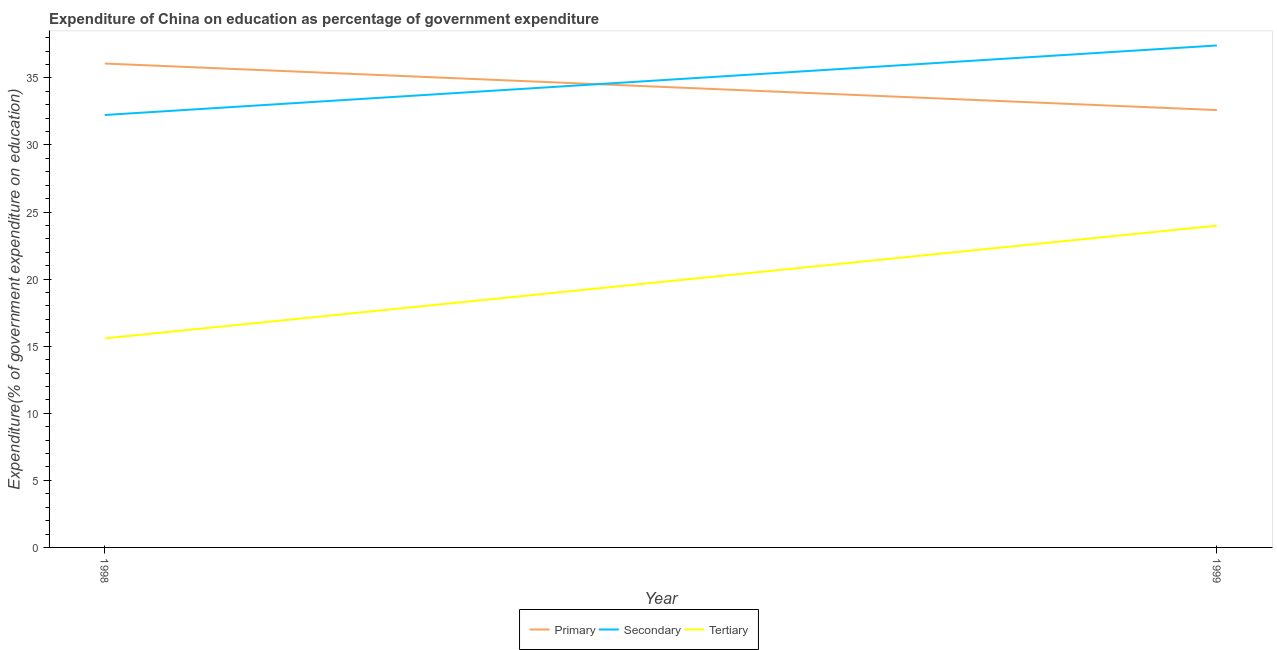Does the line corresponding to expenditure on primary education intersect with the line corresponding to expenditure on tertiary education?
Provide a succinct answer. No. What is the expenditure on tertiary education in 1999?
Provide a succinct answer. 23.98. Across all years, what is the maximum expenditure on tertiary education?
Offer a very short reply. 23.98. Across all years, what is the minimum expenditure on secondary education?
Give a very brief answer. 32.23. What is the total expenditure on secondary education in the graph?
Your response must be concise. 69.64. What is the difference between the expenditure on primary education in 1998 and that in 1999?
Your answer should be very brief. 3.47. What is the difference between the expenditure on tertiary education in 1999 and the expenditure on secondary education in 1998?
Give a very brief answer. -8.25. What is the average expenditure on tertiary education per year?
Keep it short and to the point. 19.78. In the year 1999, what is the difference between the expenditure on primary education and expenditure on secondary education?
Provide a short and direct response. -4.82. What is the ratio of the expenditure on tertiary education in 1998 to that in 1999?
Ensure brevity in your answer.  0.65. Is the expenditure on primary education in 1998 less than that in 1999?
Your answer should be very brief. No. Is the expenditure on secondary education strictly greater than the expenditure on primary education over the years?
Provide a short and direct response. No. Is the expenditure on secondary education strictly less than the expenditure on primary education over the years?
Provide a succinct answer. No. What is the difference between two consecutive major ticks on the Y-axis?
Offer a terse response. 5. Does the graph contain any zero values?
Keep it short and to the point. No. Does the graph contain grids?
Provide a succinct answer. No. Where does the legend appear in the graph?
Provide a short and direct response. Bottom center. What is the title of the graph?
Your response must be concise. Expenditure of China on education as percentage of government expenditure. Does "Other sectors" appear as one of the legend labels in the graph?
Your response must be concise. No. What is the label or title of the Y-axis?
Give a very brief answer. Expenditure(% of government expenditure on education). What is the Expenditure(% of government expenditure on education) of Primary in 1998?
Offer a very short reply. 36.06. What is the Expenditure(% of government expenditure on education) of Secondary in 1998?
Provide a short and direct response. 32.23. What is the Expenditure(% of government expenditure on education) in Tertiary in 1998?
Your answer should be compact. 15.58. What is the Expenditure(% of government expenditure on education) in Primary in 1999?
Provide a short and direct response. 32.6. What is the Expenditure(% of government expenditure on education) in Secondary in 1999?
Give a very brief answer. 37.41. What is the Expenditure(% of government expenditure on education) in Tertiary in 1999?
Give a very brief answer. 23.98. Across all years, what is the maximum Expenditure(% of government expenditure on education) of Primary?
Your response must be concise. 36.06. Across all years, what is the maximum Expenditure(% of government expenditure on education) in Secondary?
Provide a succinct answer. 37.41. Across all years, what is the maximum Expenditure(% of government expenditure on education) in Tertiary?
Give a very brief answer. 23.98. Across all years, what is the minimum Expenditure(% of government expenditure on education) of Primary?
Provide a short and direct response. 32.6. Across all years, what is the minimum Expenditure(% of government expenditure on education) in Secondary?
Provide a short and direct response. 32.23. Across all years, what is the minimum Expenditure(% of government expenditure on education) of Tertiary?
Your response must be concise. 15.58. What is the total Expenditure(% of government expenditure on education) of Primary in the graph?
Your response must be concise. 68.66. What is the total Expenditure(% of government expenditure on education) of Secondary in the graph?
Your answer should be very brief. 69.64. What is the total Expenditure(% of government expenditure on education) in Tertiary in the graph?
Offer a very short reply. 39.56. What is the difference between the Expenditure(% of government expenditure on education) in Primary in 1998 and that in 1999?
Offer a terse response. 3.47. What is the difference between the Expenditure(% of government expenditure on education) of Secondary in 1998 and that in 1999?
Provide a succinct answer. -5.18. What is the difference between the Expenditure(% of government expenditure on education) in Tertiary in 1998 and that in 1999?
Your response must be concise. -8.4. What is the difference between the Expenditure(% of government expenditure on education) in Primary in 1998 and the Expenditure(% of government expenditure on education) in Secondary in 1999?
Provide a short and direct response. -1.35. What is the difference between the Expenditure(% of government expenditure on education) of Primary in 1998 and the Expenditure(% of government expenditure on education) of Tertiary in 1999?
Make the answer very short. 12.08. What is the difference between the Expenditure(% of government expenditure on education) of Secondary in 1998 and the Expenditure(% of government expenditure on education) of Tertiary in 1999?
Provide a short and direct response. 8.25. What is the average Expenditure(% of government expenditure on education) of Primary per year?
Provide a succinct answer. 34.33. What is the average Expenditure(% of government expenditure on education) in Secondary per year?
Ensure brevity in your answer.  34.82. What is the average Expenditure(% of government expenditure on education) of Tertiary per year?
Your response must be concise. 19.78. In the year 1998, what is the difference between the Expenditure(% of government expenditure on education) in Primary and Expenditure(% of government expenditure on education) in Secondary?
Your answer should be very brief. 3.83. In the year 1998, what is the difference between the Expenditure(% of government expenditure on education) of Primary and Expenditure(% of government expenditure on education) of Tertiary?
Provide a short and direct response. 20.48. In the year 1998, what is the difference between the Expenditure(% of government expenditure on education) of Secondary and Expenditure(% of government expenditure on education) of Tertiary?
Provide a short and direct response. 16.65. In the year 1999, what is the difference between the Expenditure(% of government expenditure on education) of Primary and Expenditure(% of government expenditure on education) of Secondary?
Provide a short and direct response. -4.82. In the year 1999, what is the difference between the Expenditure(% of government expenditure on education) of Primary and Expenditure(% of government expenditure on education) of Tertiary?
Your answer should be compact. 8.61. In the year 1999, what is the difference between the Expenditure(% of government expenditure on education) in Secondary and Expenditure(% of government expenditure on education) in Tertiary?
Your answer should be very brief. 13.43. What is the ratio of the Expenditure(% of government expenditure on education) in Primary in 1998 to that in 1999?
Make the answer very short. 1.11. What is the ratio of the Expenditure(% of government expenditure on education) of Secondary in 1998 to that in 1999?
Give a very brief answer. 0.86. What is the ratio of the Expenditure(% of government expenditure on education) of Tertiary in 1998 to that in 1999?
Give a very brief answer. 0.65. What is the difference between the highest and the second highest Expenditure(% of government expenditure on education) in Primary?
Your answer should be compact. 3.47. What is the difference between the highest and the second highest Expenditure(% of government expenditure on education) of Secondary?
Your answer should be very brief. 5.18. What is the difference between the highest and the second highest Expenditure(% of government expenditure on education) in Tertiary?
Offer a terse response. 8.4. What is the difference between the highest and the lowest Expenditure(% of government expenditure on education) of Primary?
Make the answer very short. 3.47. What is the difference between the highest and the lowest Expenditure(% of government expenditure on education) of Secondary?
Make the answer very short. 5.18. What is the difference between the highest and the lowest Expenditure(% of government expenditure on education) in Tertiary?
Offer a very short reply. 8.4. 